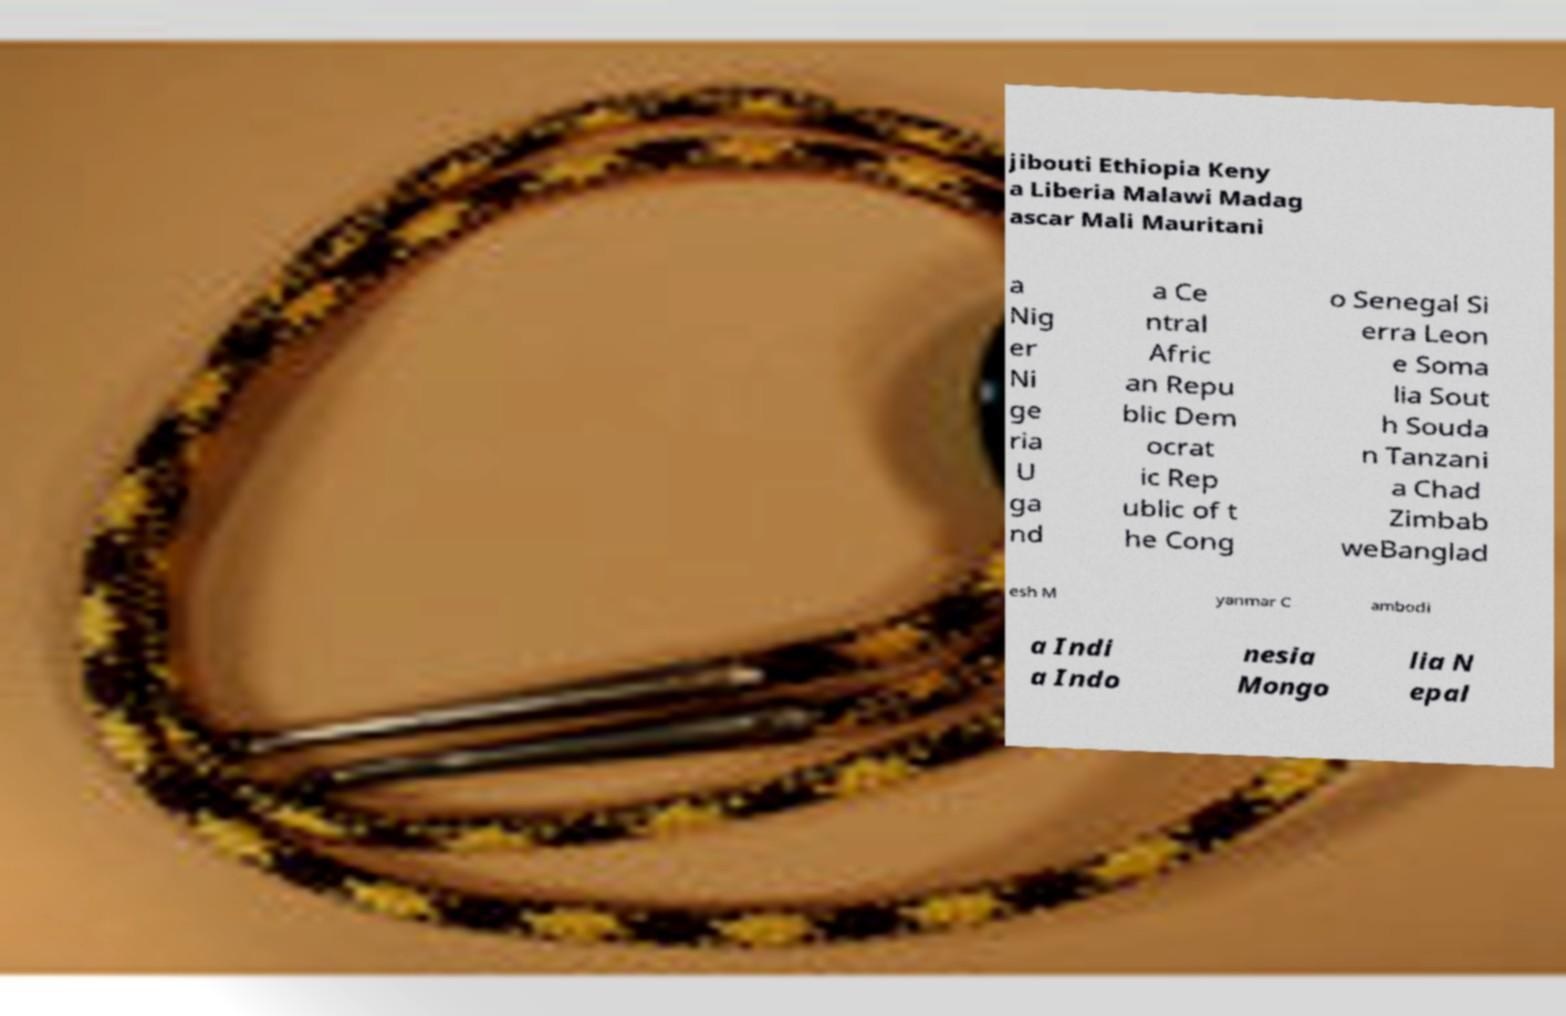For documentation purposes, I need the text within this image transcribed. Could you provide that? jibouti Ethiopia Keny a Liberia Malawi Madag ascar Mali Mauritani a Nig er Ni ge ria U ga nd a Ce ntral Afric an Repu blic Dem ocrat ic Rep ublic of t he Cong o Senegal Si erra Leon e Soma lia Sout h Souda n Tanzani a Chad Zimbab weBanglad esh M yanmar C ambodi a Indi a Indo nesia Mongo lia N epal 